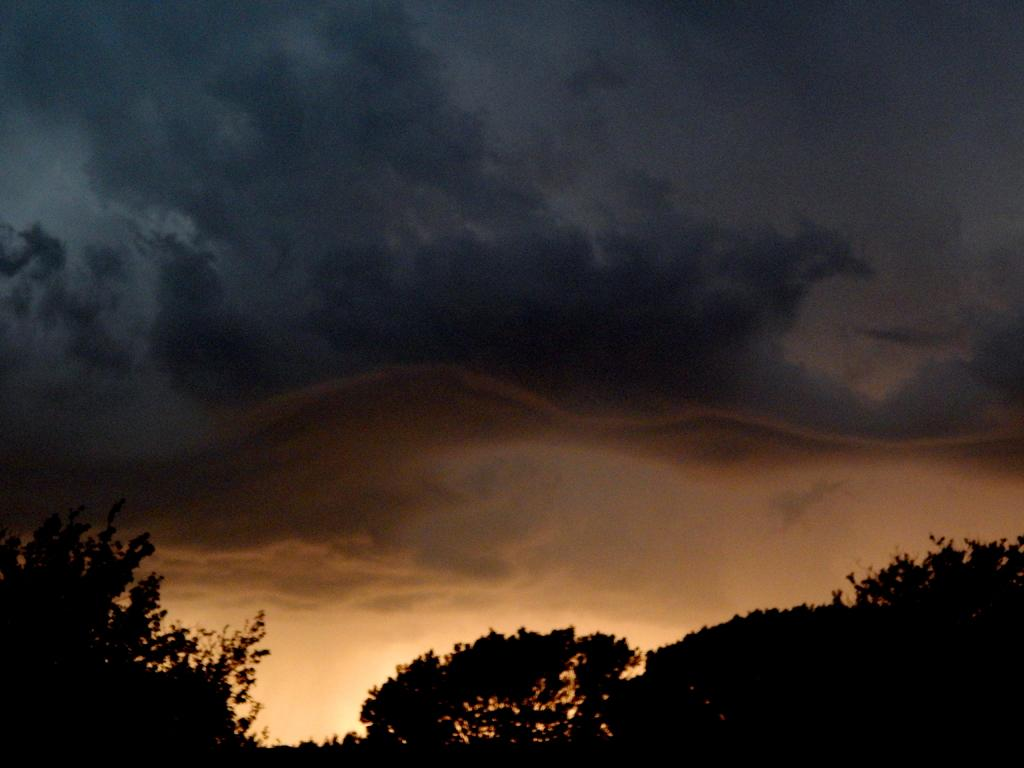What type of vegetation can be seen in the image? There are trees in the image. What is the condition of the sky in the image? The sky is covered with black color clouds in the image. How many oranges are hanging from the trees in the image? There are no oranges present in the image; it only features trees and clouds. What type of pain is being experienced by the trees in the image? There is no indication of pain in the image; the trees and clouds are inanimate objects and do not experience pain. 